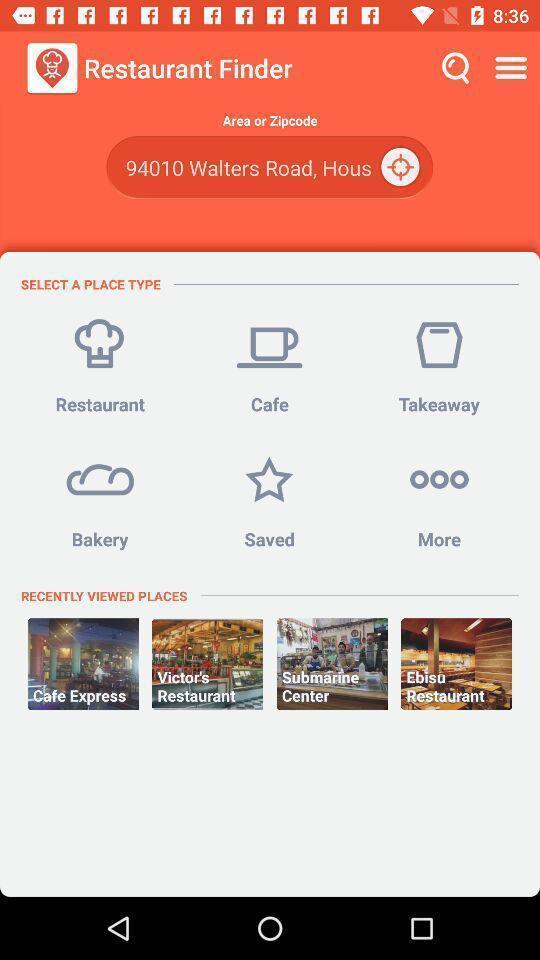Describe the content in this image. Search page for finding restaurants on finder app. 